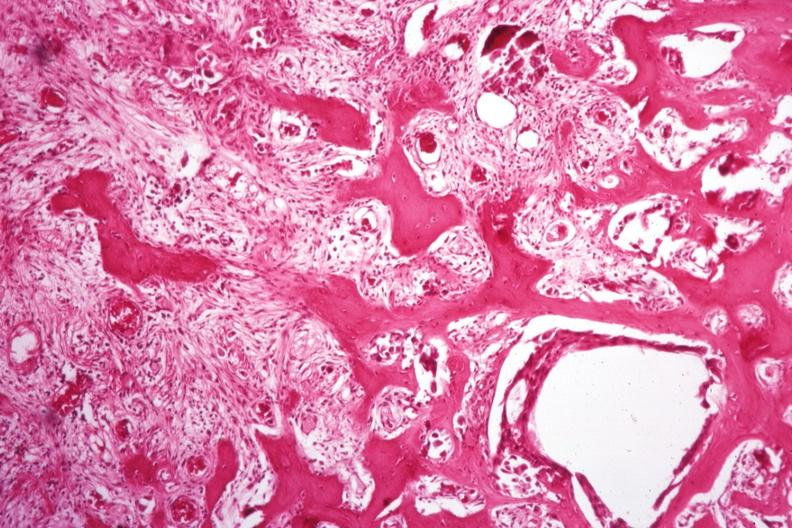does this image show nice new bone formation tumor difficult to see?
Answer the question using a single word or phrase. Yes 